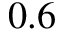Convert formula to latex. <formula><loc_0><loc_0><loc_500><loc_500>0 . 6</formula> 